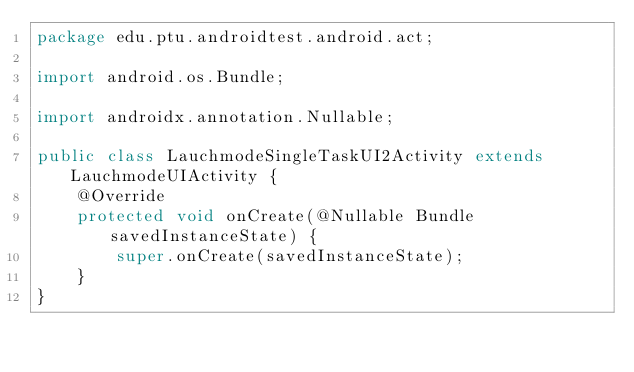<code> <loc_0><loc_0><loc_500><loc_500><_Java_>package edu.ptu.androidtest.android.act;

import android.os.Bundle;

import androidx.annotation.Nullable;

public class LauchmodeSingleTaskUI2Activity extends LauchmodeUIActivity {
    @Override
    protected void onCreate(@Nullable Bundle savedInstanceState) {
        super.onCreate(savedInstanceState);
    }
}
</code> 